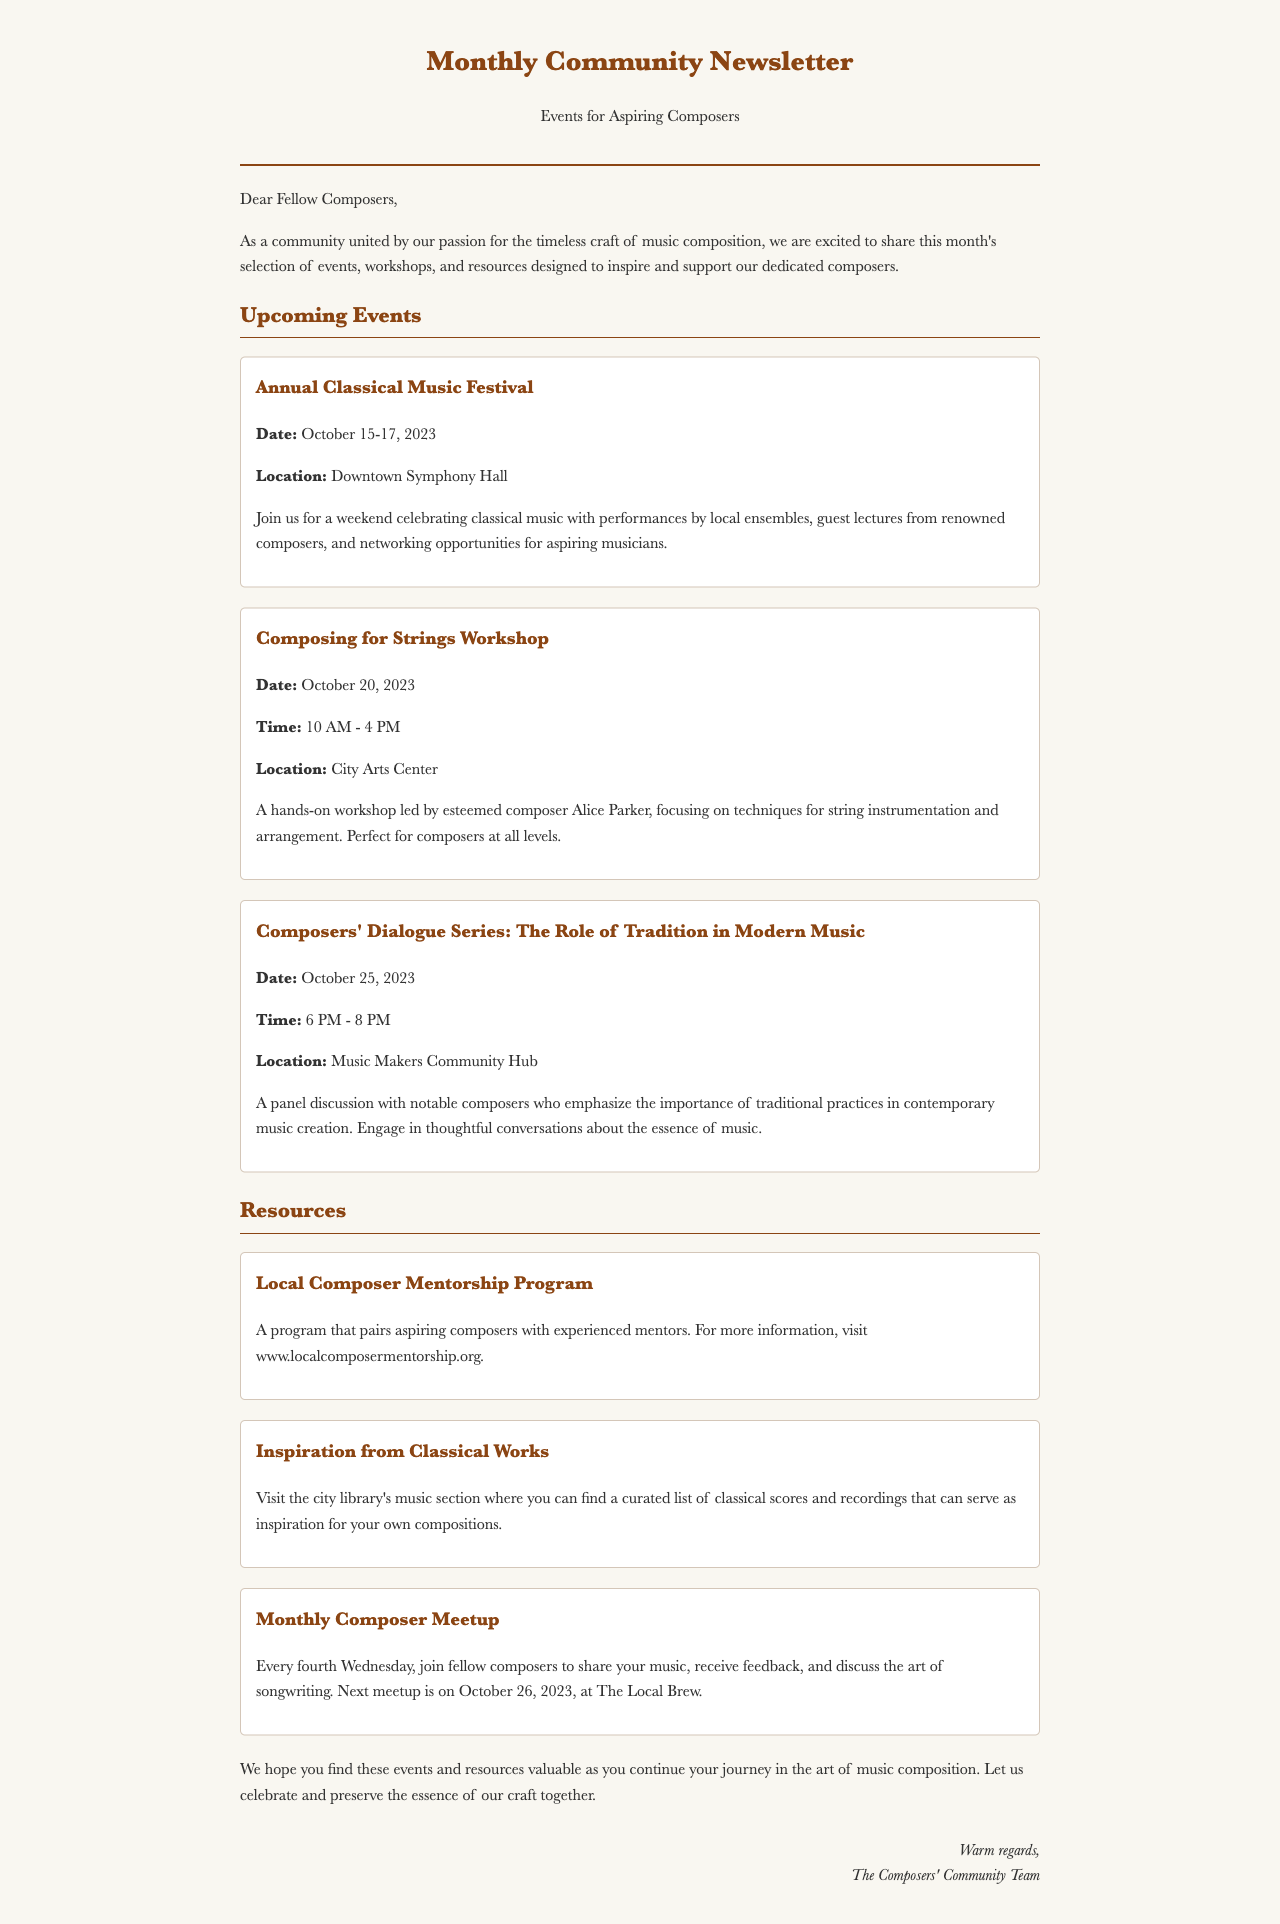what are the dates for the Annual Classical Music Festival? The festival takes place over a three-day period as specified in the document.
Answer: October 15-17, 2023 who is leading the Composing for Strings Workshop? The document mentions the name of the esteemed composer leading the workshop.
Answer: Alice Parker when is the next Monthly Composer Meetup? The document states the specific date of the upcoming meetup.
Answer: October 26, 2023 where is the Composers' Dialogue Series being held? The location of the panel discussion is indicated in the event details.
Answer: Music Makers Community Hub what is the focus of the Composers' Dialogue Series? The document outlines the main theme of the discussion in the event description.
Answer: The Role of Tradition in Modern Music how often does the Monthly Composer Meetup occur? The frequency of the meetup is mentioned in the resource section.
Answer: Every fourth Wednesday what is the purpose of the Local Composer Mentorship Program? The document briefly describes what the mentorship program aims to achieve for aspiring composers.
Answer: Pair aspiring composers with experienced mentors what type of music resources can be found at the local library? The resource section notes what kind of materials are available for inspiration.
Answer: Classical scores and recordings 